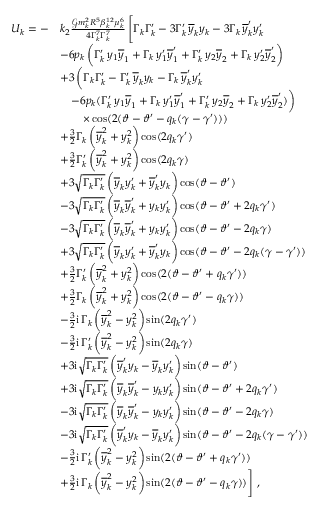Convert formula to latex. <formula><loc_0><loc_0><loc_500><loc_500>\begin{array} { r l } { U _ { k } = - } & { k _ { 2 } \frac { \mathcal { G } m _ { k } ^ { 2 } R ^ { 5 } \beta _ { k } ^ { 1 2 } \mu _ { k } ^ { 6 } } { 4 \Gamma _ { k } ^ { 7 } \Gamma _ { k } ^ { 7 } } \, \left [ \Gamma _ { k } \Gamma _ { k } ^ { \prime } - 3 \Gamma _ { k } ^ { \prime } \, \overline { y } _ { k } y _ { k } - 3 \Gamma _ { k } \, \overline { y } _ { k } ^ { \prime } y _ { k } ^ { \prime } } \\ & { - 6 p _ { k } \, \left ( \Gamma _ { k } ^ { \prime } \, y _ { 1 } \overline { y } _ { 1 } + \Gamma _ { k } \, y _ { 1 } ^ { \prime } \overline { y } _ { 1 } ^ { \prime } + \Gamma _ { k } ^ { \prime } \, y _ { 2 } \overline { y } _ { 2 } + \Gamma _ { k } \, y _ { 2 } ^ { \prime } \overline { y } _ { 2 } ^ { \prime } \right ) } \\ & { + 3 \, \left ( \Gamma _ { k } \Gamma _ { k } ^ { \prime } - \Gamma _ { k } ^ { \prime } \, \overline { y } _ { k } y _ { k } - \Gamma _ { k } \, \overline { y } _ { k } ^ { \prime } y _ { k } ^ { \prime } } \\ & { \quad - 6 p _ { k } ( \Gamma _ { k } ^ { \prime } \, y _ { 1 } \overline { y } _ { 1 } + \Gamma _ { k } \, y _ { 1 } ^ { \prime } \overline { y } _ { 1 } ^ { \prime } + \Gamma _ { k } ^ { \prime } \, y _ { 2 } \overline { y } _ { 2 } + \Gamma _ { k } \, y _ { 2 } ^ { \prime } \overline { y } _ { 2 } ^ { \prime } ) \right ) } \\ & { \quad \times \cos ( 2 ( \vartheta - \vartheta ^ { \prime } - q _ { k } ( \gamma - \gamma ^ { \prime } ) ) ) } \\ & { + \frac { 3 } { 2 } \Gamma _ { k } \, \left ( \overline { y } _ { k } ^ { 2 } + y _ { k } ^ { 2 } \right ) \cos ( 2 q _ { k } \gamma ^ { \prime } ) } \\ & { + \frac { 3 } { 2 } \Gamma _ { k } ^ { \prime } \, \left ( \overline { y } _ { k } ^ { 2 } + y _ { k } ^ { 2 } \right ) \cos ( 2 q _ { k } \gamma ) } \\ & { + 3 \sqrt { \Gamma _ { k } \Gamma _ { k } ^ { \prime } } \, \left ( \overline { y } _ { k } y _ { k } ^ { \prime } + \overline { y } _ { k } ^ { \prime } y _ { k } \right ) \cos ( \vartheta - \vartheta ^ { \prime } ) } \\ & { - 3 \sqrt { \Gamma _ { k } \Gamma _ { k } ^ { \prime } } \, \left ( \overline { y } _ { k } \overline { y } _ { k } ^ { \prime } + y _ { k } y _ { k } ^ { \prime } \right ) \cos ( \vartheta - \vartheta ^ { \prime } + 2 q _ { k } \gamma ^ { \prime } ) } \\ & { - 3 \sqrt { \Gamma _ { k } \Gamma _ { k } ^ { \prime } } \, \left ( \overline { y } _ { k } \overline { y } _ { k } ^ { \prime } + y _ { k } y _ { k } ^ { \prime } \right ) \cos ( \vartheta - \vartheta ^ { \prime } - 2 q _ { k } \gamma ) } \\ & { + 3 \sqrt { \Gamma _ { k } \Gamma _ { k } ^ { \prime } } \, \left ( \overline { y } _ { k } y _ { k } ^ { \prime } + \overline { y } _ { k } ^ { \prime } y _ { k } \right ) \cos ( \vartheta - \vartheta ^ { \prime } - 2 q _ { k } ( \gamma - \gamma ^ { \prime } ) ) } \\ & { + \frac { 3 } { 2 } \Gamma _ { k } ^ { \prime } \, \left ( \overline { y } _ { k } ^ { 2 } + y _ { k } ^ { 2 } \right ) \cos ( 2 ( \vartheta - \vartheta ^ { \prime } + q _ { k } \gamma ^ { \prime } ) ) } \\ & { + \frac { 3 } { 2 } \Gamma _ { k } \, \left ( \overline { y } _ { k } ^ { 2 } + y _ { k } ^ { 2 } \right ) \cos ( 2 ( \vartheta - \vartheta ^ { \prime } - q _ { k } \gamma ) ) } \\ & { - \frac { 3 } { 2 } i \, \Gamma _ { k } \, \left ( \overline { y } _ { k } ^ { 2 } - y _ { k } ^ { 2 } \right ) \sin ( 2 q _ { k } \gamma ^ { \prime } ) } \\ & { - \frac { 3 } { 2 } i \, \Gamma _ { k } ^ { \prime } \, \left ( \overline { y } _ { k } ^ { 2 } - y _ { k } ^ { 2 } \right ) \sin ( 2 q _ { k } \gamma ) } \\ & { + 3 i \sqrt { \Gamma _ { k } \Gamma _ { k } ^ { \prime } } \, \left ( \overline { y } _ { k } ^ { \prime } y _ { k } - \overline { y } _ { k } y _ { k } ^ { \prime } \right ) \sin ( \vartheta - \vartheta ^ { \prime } ) } \\ & { + 3 i \sqrt { \Gamma _ { k } \Gamma _ { k } ^ { \prime } } \, \left ( \overline { y } _ { k } \overline { y } _ { k } ^ { \prime } - y _ { k } y _ { k } ^ { \prime } \right ) \sin ( \vartheta - \vartheta ^ { \prime } + 2 q _ { k } \gamma ^ { \prime } ) } \\ & { - 3 i \sqrt { \Gamma _ { k } \Gamma _ { k } ^ { \prime } } \, \left ( \overline { y } _ { k } \overline { y } _ { k } ^ { \prime } - y _ { k } y _ { k } ^ { \prime } \right ) \sin ( \vartheta - \vartheta ^ { \prime } - 2 q _ { k } \gamma ) } \\ & { - 3 i \sqrt { \Gamma _ { k } \Gamma _ { k } ^ { \prime } } \, \left ( \overline { y } _ { k } ^ { \prime } y _ { k } - \overline { y } _ { k } y _ { k } ^ { \prime } \right ) \sin ( \vartheta - \vartheta ^ { \prime } - 2 q _ { k } ( \gamma - \gamma ^ { \prime } ) ) } \\ & { - \frac { 3 } { 2 } i \, \Gamma _ { k } ^ { \prime } \, \left ( \overline { y } _ { k } ^ { 2 } - y _ { k } ^ { 2 } \right ) \sin ( 2 ( \vartheta - \vartheta ^ { \prime } + q _ { k } \gamma ^ { \prime } ) ) } \\ & { + \frac { 3 } { 2 } i \, \Gamma _ { k } \, \left ( \overline { y } _ { k } ^ { 2 } - y _ { k } ^ { 2 } \right ) \sin ( 2 ( \vartheta - \vartheta ^ { \prime } - q _ { k } \gamma ) ) \right ] \ , } \end{array}</formula> 